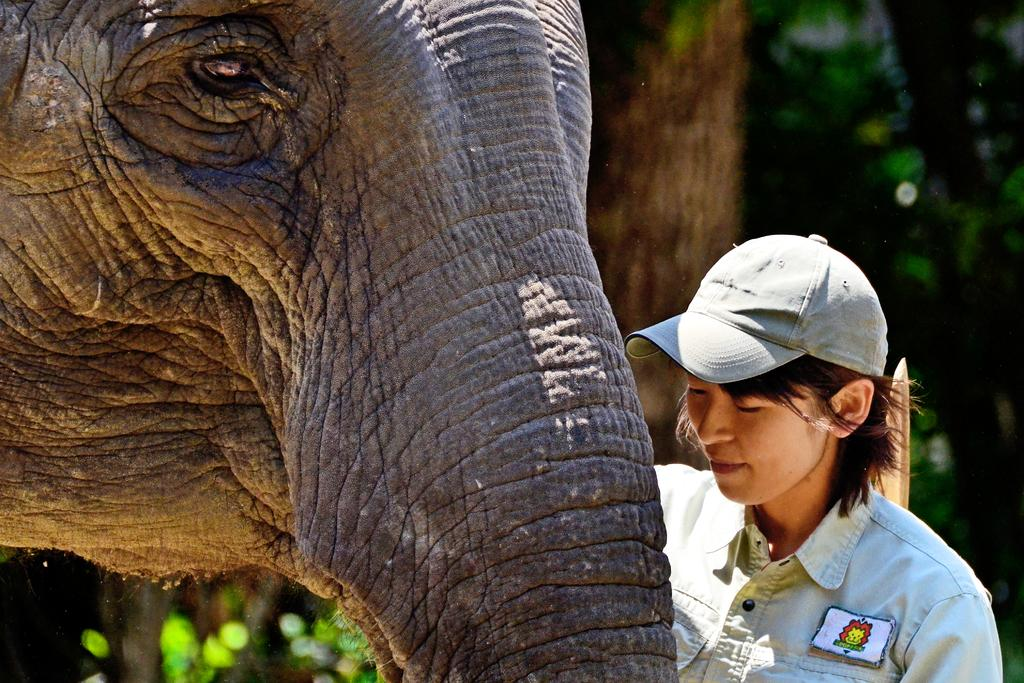Who is the main subject in the image? There is a girl in the image. What is the girl doing in the image? The girl is standing beside an elephant. What books is the girl reading while standing beside the elephant? There is no mention of books or reading in the image; the girl is simply standing beside an elephant. 